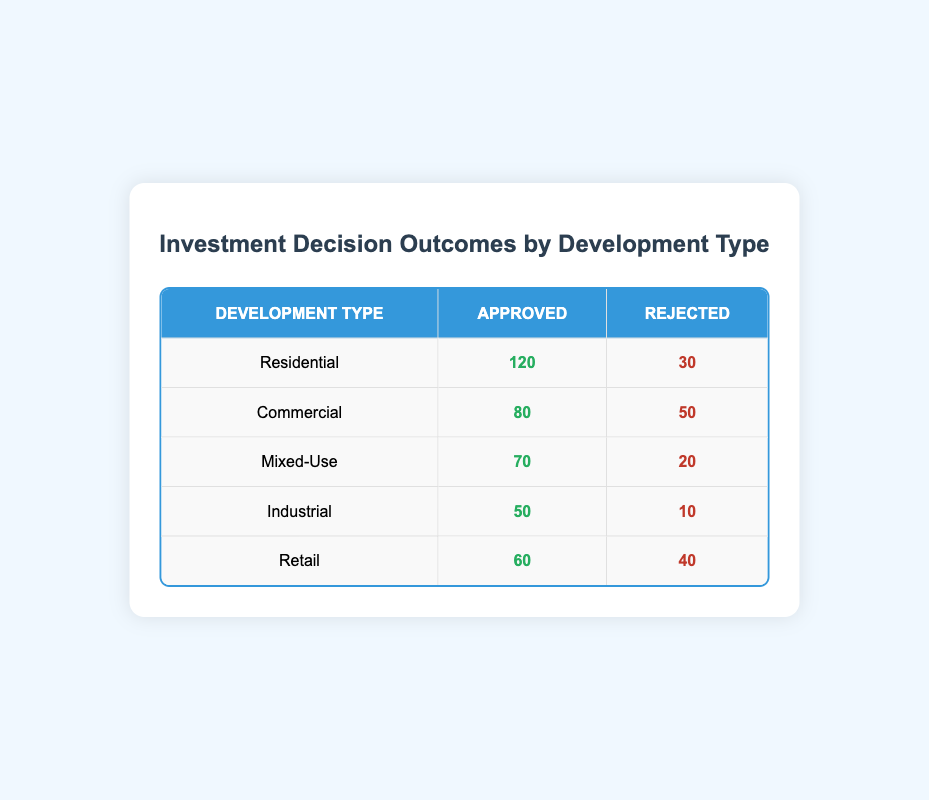What is the number of approved Residential developments? The table lists the Development Type as "Residential" with the corresponding value under Approved as 120.
Answer: 120 How many Industrial developments were rejected? Looking at the row for Industrial, the Rejected column shows 10.
Answer: 10 Which development type had the highest number of rejected outcomes? By comparing the rejected counts for each type, Commercial has the highest with 50 rejected.
Answer: Commercial What is the total number of approved developments across all types? Summing the approved numbers: 120 (Residential) + 80 (Commercial) + 70 (Mixed-Use) + 50 (Industrial) + 60 (Retail) = 380.
Answer: 380 Is the number of approved Mixed-Use developments greater than the number of approved Industrial developments? The approved count for Mixed-Use is 70 and for Industrial, it is 50. Since 70 is greater than 50 the statement is true.
Answer: Yes What percentage of Retail developments were rejected? The total for Retail is 100 (60 approved + 40 rejected). The rejected percentage is (40/100) * 100 = 40%.
Answer: 40% What is the difference in the number of approved developments between Residential and Commercial? The approved count for Residential is 120 and for Commercial is 80. Therefore, the difference is 120 - 80 = 40.
Answer: 40 If we combined the approved and rejected counts for Mixed-Use, what would the total be? Adding both the approved (70) and rejected (20) counts for Mixed-Use gives 70 + 20 = 90.
Answer: 90 Which type had the lowest approval rate? To determine the approval rate for each type: Residential (120/150), Commercial (80/130), Mixed-Use (70/90), Industrial (50/60), Retail (60/100). The lowest rate is for Industrial which results in approximately 83.33%.
Answer: Industrial 